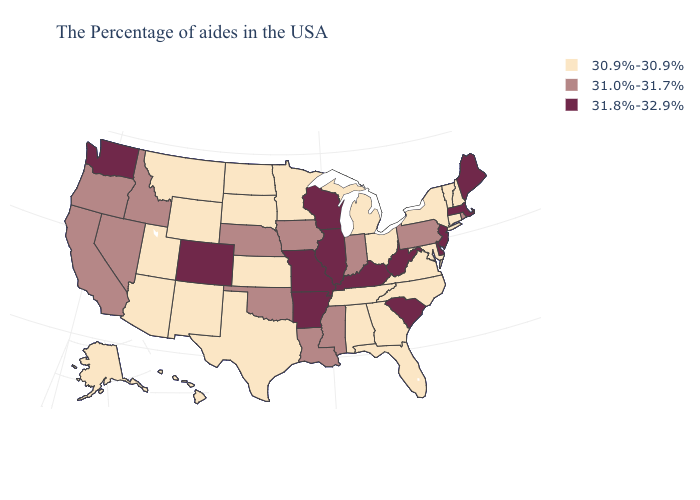Is the legend a continuous bar?
Write a very short answer. No. What is the value of Mississippi?
Give a very brief answer. 31.0%-31.7%. What is the lowest value in the Northeast?
Give a very brief answer. 30.9%-30.9%. What is the value of South Carolina?
Give a very brief answer. 31.8%-32.9%. Among the states that border South Carolina , which have the highest value?
Write a very short answer. North Carolina, Georgia. What is the value of Washington?
Be succinct. 31.8%-32.9%. What is the value of Texas?
Keep it brief. 30.9%-30.9%. Among the states that border Oklahoma , does Kansas have the highest value?
Be succinct. No. Which states have the highest value in the USA?
Write a very short answer. Maine, Massachusetts, New Jersey, Delaware, South Carolina, West Virginia, Kentucky, Wisconsin, Illinois, Missouri, Arkansas, Colorado, Washington. What is the value of Massachusetts?
Keep it brief. 31.8%-32.9%. Does Illinois have the highest value in the USA?
Give a very brief answer. Yes. Which states hav the highest value in the West?
Short answer required. Colorado, Washington. Does Washington have the lowest value in the USA?
Give a very brief answer. No. Does Kentucky have the lowest value in the USA?
Be succinct. No. Does Illinois have the highest value in the MidWest?
Be succinct. Yes. 